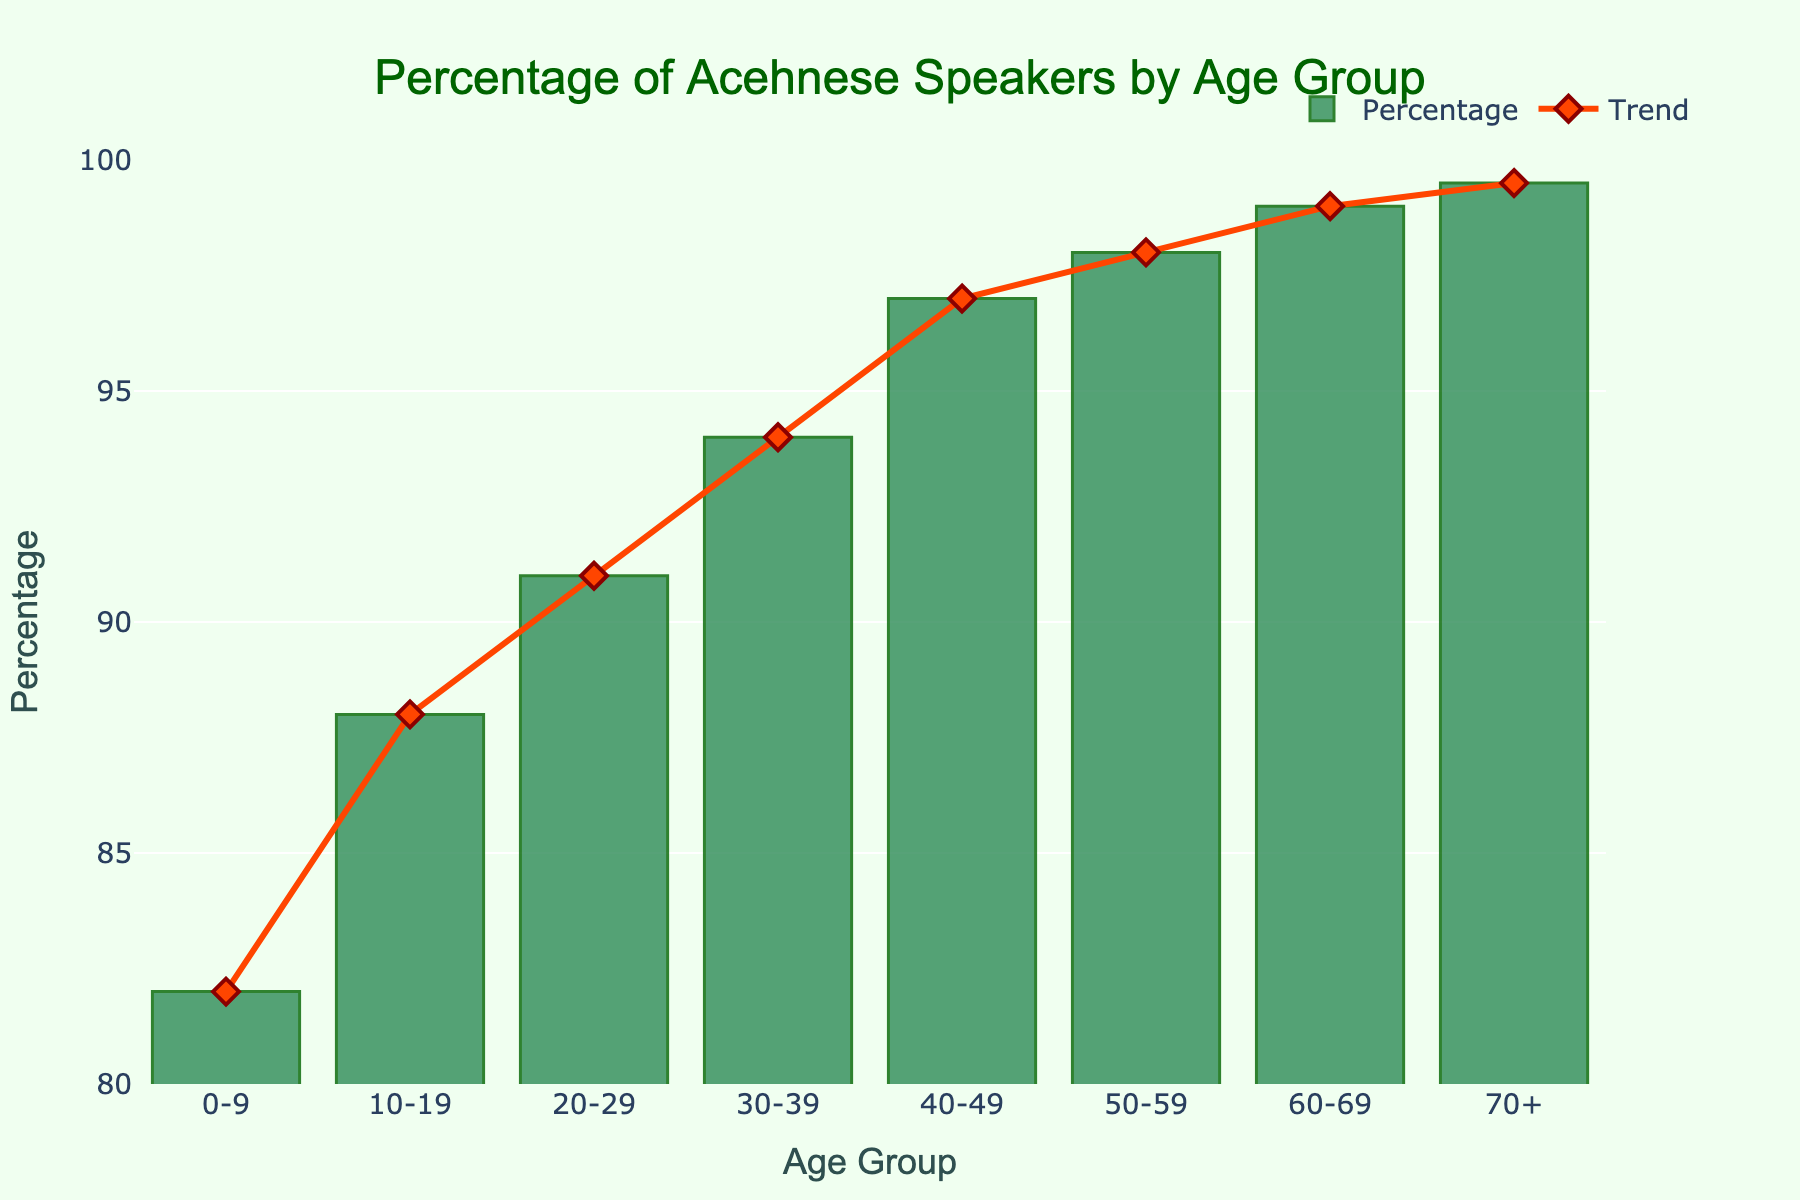What's the age group with the highest percentage of Acehnese speakers? Look at the bar chart and observe the bar with the greatest height. The highest percentage is faced by the age group with the tallest bar, which is the 70+ age group with 99.5%.
Answer: 70+ Is there any age group where the percentage of Acehnese speakers is exactly 97%? Check for the bar with a height that corresponds to the value of 97%. The age group 40-49 has a percentage of 97%
Answer: 40-49 What's the average percentage of Acehnese speakers between age groups 20-29 and 50-59? Find the percentage values for both groups (91% for 20-29 and 98% for 50-59), sum them up and divide by two. The calculation is (91 + 98) / 2 = 94.5
Answer: 94.5 By how many percentage points does the age group 30-39 exceed the age group 0-9 in Acehnese speakers? Subtract the percentage of Acehnese speakers in the 0-9 age group from the 30-39 age group. The calculation is 94% - 82% = 12 percentage points
Answer: 12 Which age group has the smallest increase in the percentage of Acehnese speakers compared to the previous age group? Look at the changes between each age group's percentage. The age groups 60-69 and 70+ each show a 0.5% increase from the previous groups, which is the smallest increase.
Answer: 60-69 to 70+ What's the combined sum of percentages for the age groups 50-59 and 60-69? Add the percentage values for both groups, which are 98% for 50-59 and 99% for 60-69. The calculation is 98 + 99 = 197
Answer: 197 How much higher is the percentage of Acehnese speakers in the 40-49 age group than in the 10-19 age group? Compare the percentages of the two groups by subtracting the percentage for the 10-19 group from that of the 40-49 group. The calculation is 97% - 88% = 9
Answer: 9 Which age group's bar is represented in a reddish color trend line? The trend line is visualized in a reddish color, which is used for highlighting all age groups in the secondary axis. Therefore, all age groups have this reddish trend line.
Answer: all What is the overall trend in the percentage of Acehnese speakers from younger to older age groups? Examining the trend line, the general increase in percentage can be observed as it moves from left (younger) to right (older) age groups. More precisely, it shows a significant increase in percentage with age.
Answer: increasing 